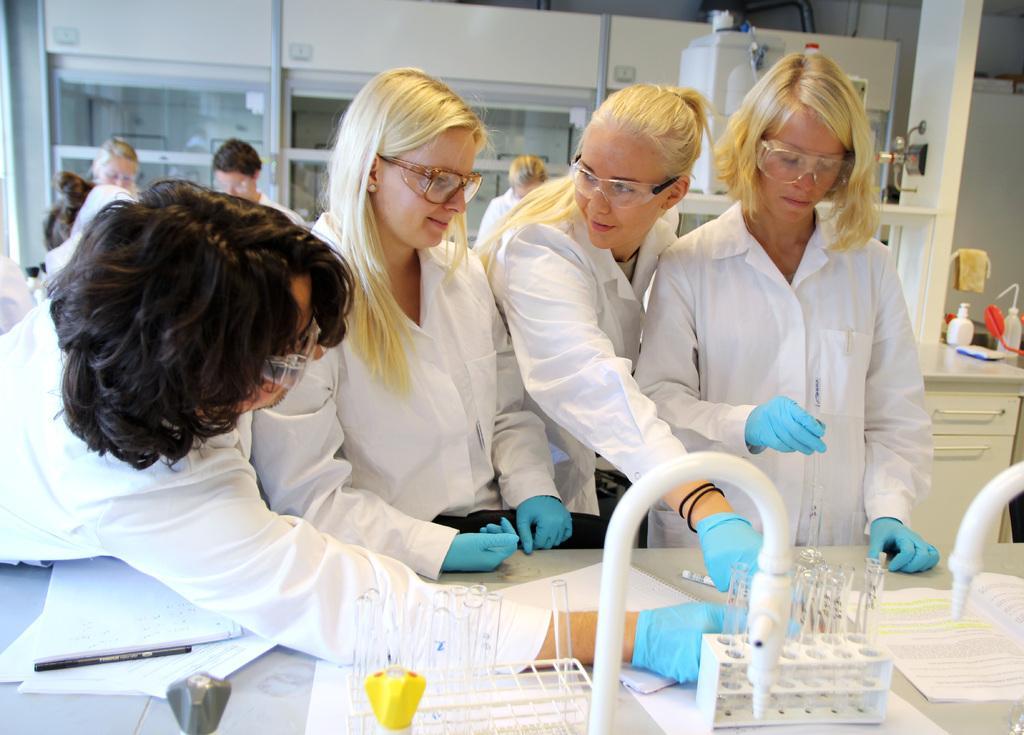Please provide a concise description of this image. In this image we can see few persons. At the bottom we can see few objects on the table. Behind the persons we can see a glass wall and few objects. On the right side, we can see few objects and a table. 